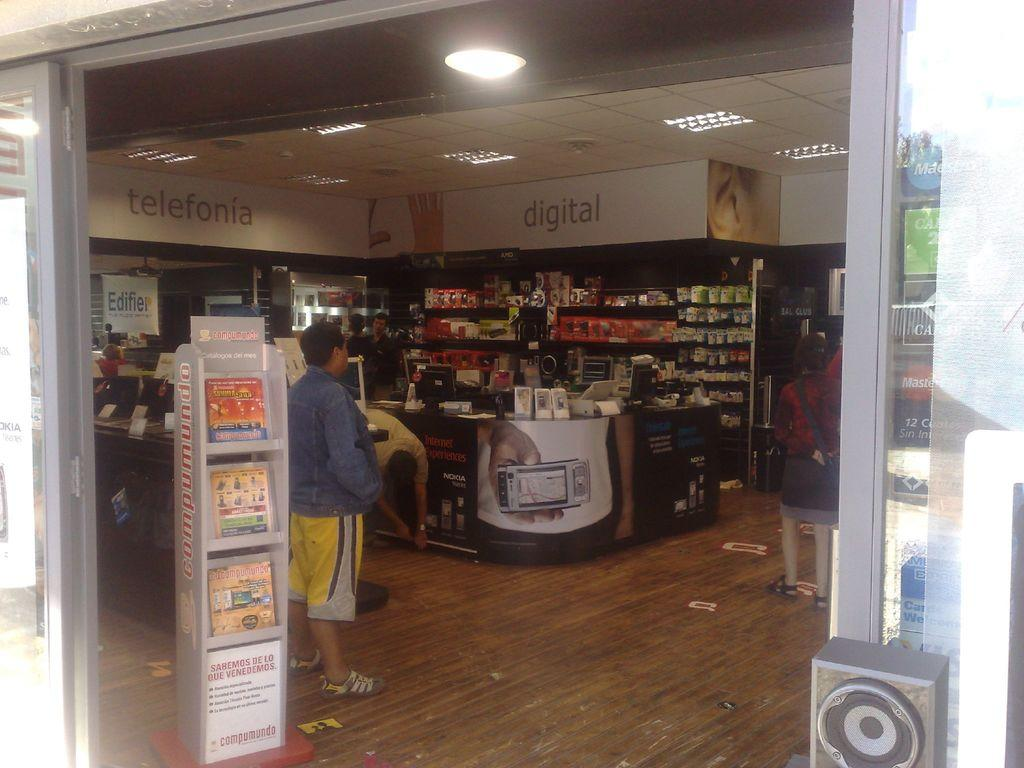<image>
Present a compact description of the photo's key features. a man in the supermarket with big words telefonia and digital 